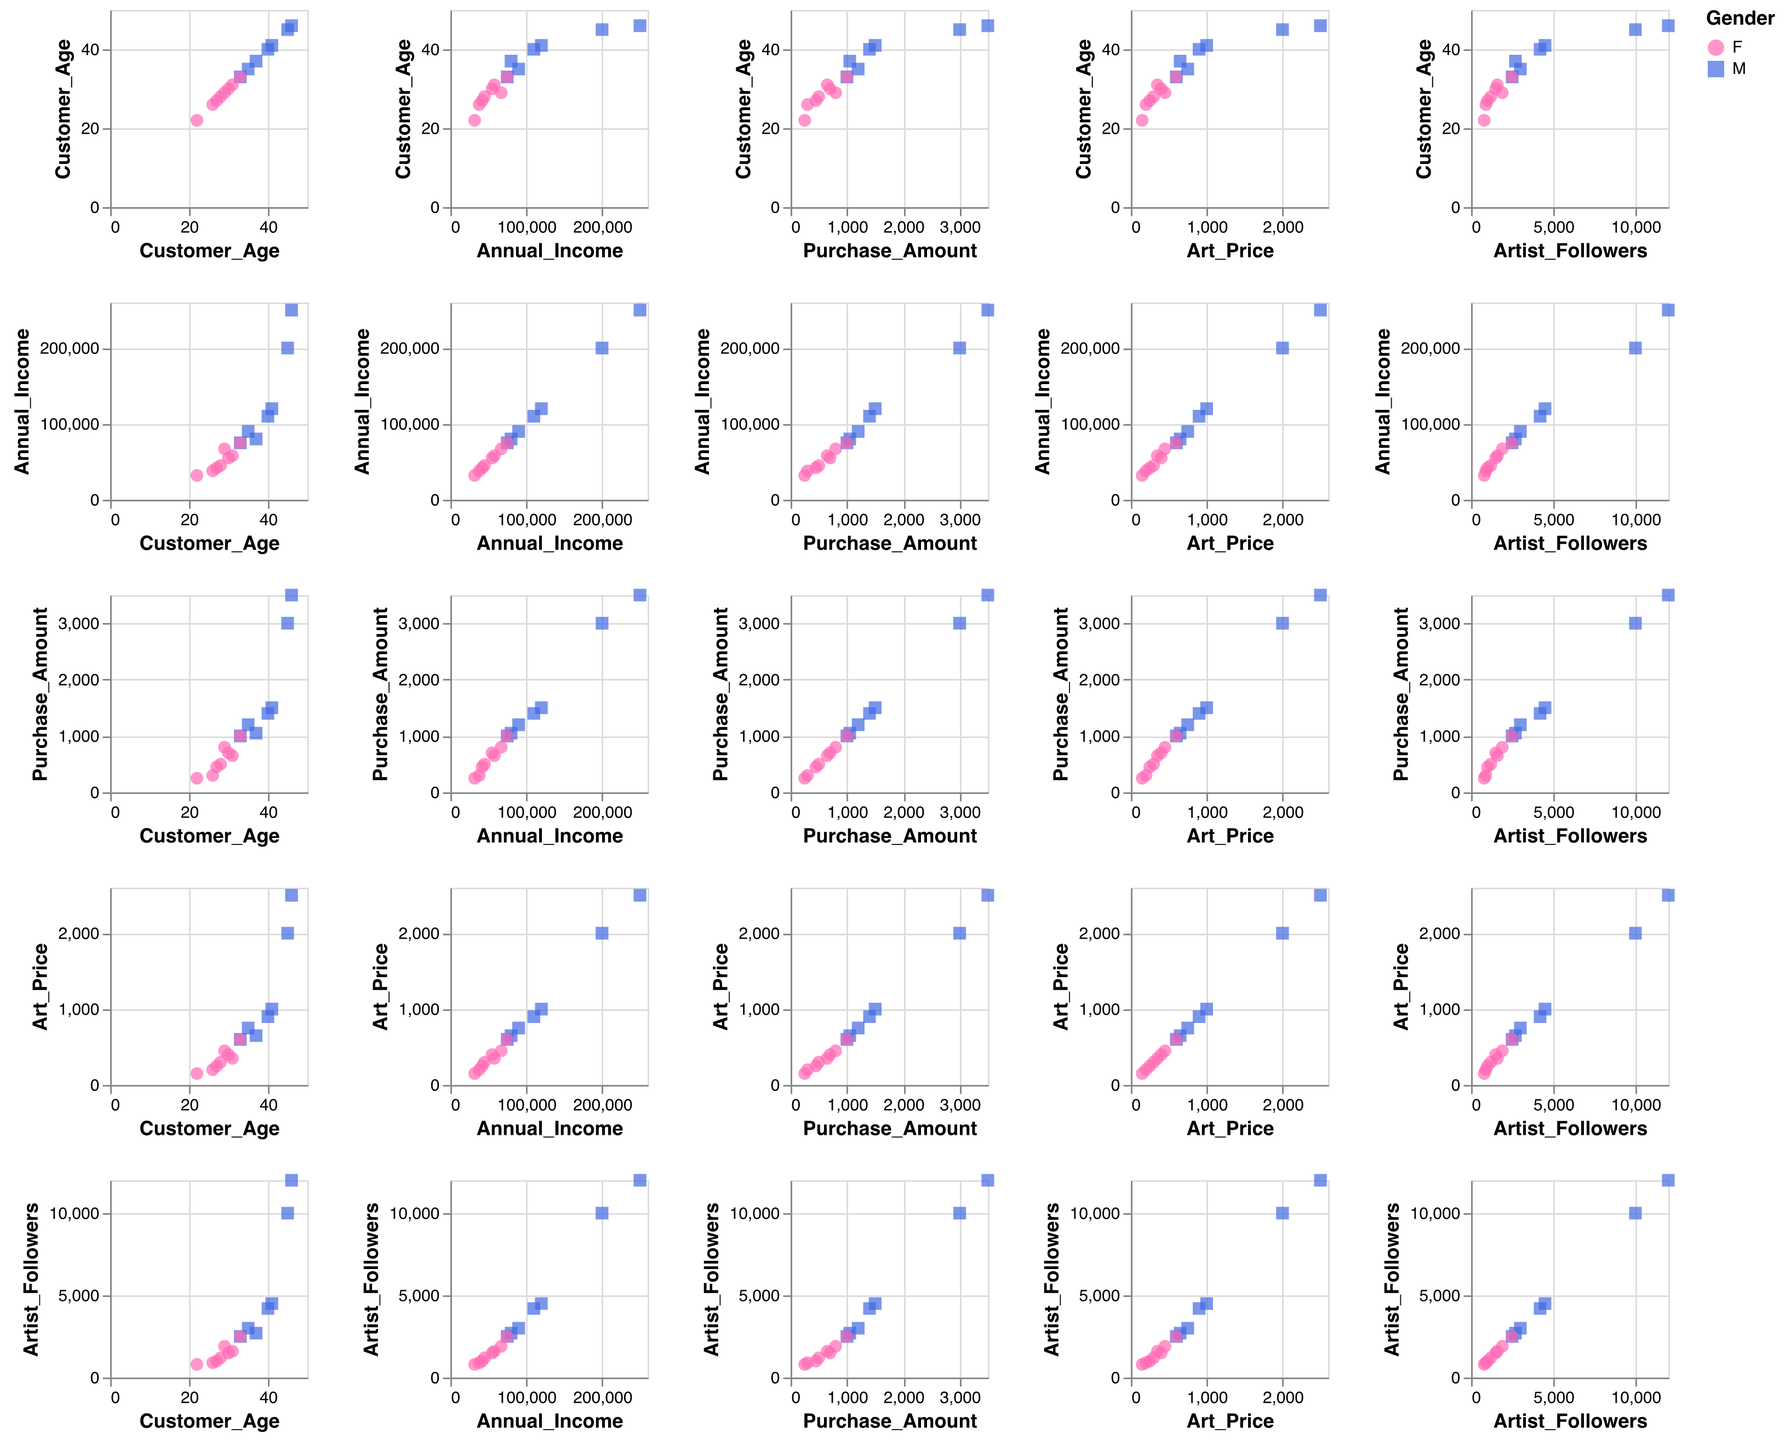How many data points are in the plot? Count the number of rows in the data. There are 15 rows representing 15 data points.
Answer: 15 What is the highest Annual Income recorded? Scan the Annual Income column and identify the maximum value, which is $250,000.
Answer: 250,000 Are there more male or female customers in the dataset? Count the occurrences of 'M' and 'F' in the Gender column. There are 7 females and 8 males in the dataset.
Answer: Males Which customer has the highest Purchase Amount? Compare the Purchase Amounts and find that the customer with Annual Income $250,000 has the highest Purchase Amount of $3,500.
Answer: Customer with $250,000 Annual Income Is the highest Art Price associated with the highest number of Artist Followers? The highest Art Price is $2,500 and the corresponding number of Artist Followers is $12,000, which is indeed the highest number of followers.
Answer: Yes What is the average Purchase Amount? Sum all the Purchase Amounts (500 + 1200 + 250 + 1500 + 700 + 3000 + 300 + 1000 + 800 + 1400 + 650 + 3500 + 450 + 1050 + 1000) which totals 18000, then divide by the number of data points (15). The average is 18000 / 15 = 1200.
Answer: 1200 How does Purchase Amount correlate with Annual Income? Observe the scatter plots where Purchase Amount and Annual Income are the axes. There is a positive correlation as higher Annual Income tends to correspond to higher Purchase Amounts.
Answer: Positive correlation Are customers who purchase art priced above $1000 generally older or younger? Check the scatter plots where Art Price is above $1000 and observe the Customer Age. Customers with higher Art Prices seem to be older, around 41 to 46 years old.
Answer: Older Which gender tends to follow artists with more followers? By comparing scatter plots, it appears that male customers tend to follow artists with more followers. For instance, males have high follower counts like 12000, 4500, and 10000, whereas female maximums are lower.
Answer: Male Does a higher number of Artist Followers influence Purchase Amounts noticeably? Observing the scatter plots between Artist Followers and Purchase Amount, there isn't a clear, strong correlation suggesting that more followers always lead to higher purchase amounts. Some high followers have lower purchases, and vice versa.
Answer: No clear influence 